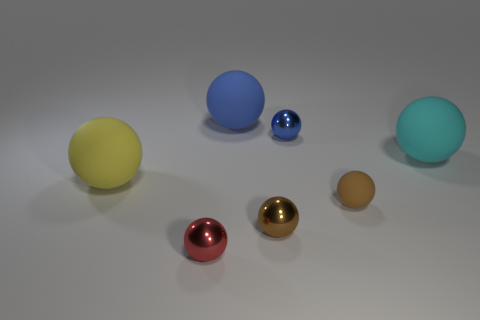Subtract 5 balls. How many balls are left? 2 Subtract all big yellow balls. How many balls are left? 6 Subtract all cyan balls. How many balls are left? 6 Add 1 metal objects. How many objects exist? 8 Subtract all brown spheres. Subtract all purple cylinders. How many spheres are left? 5 Subtract all brown matte balls. Subtract all tiny brown matte spheres. How many objects are left? 5 Add 6 tiny red things. How many tiny red things are left? 7 Add 7 brown objects. How many brown objects exist? 9 Subtract 1 yellow spheres. How many objects are left? 6 